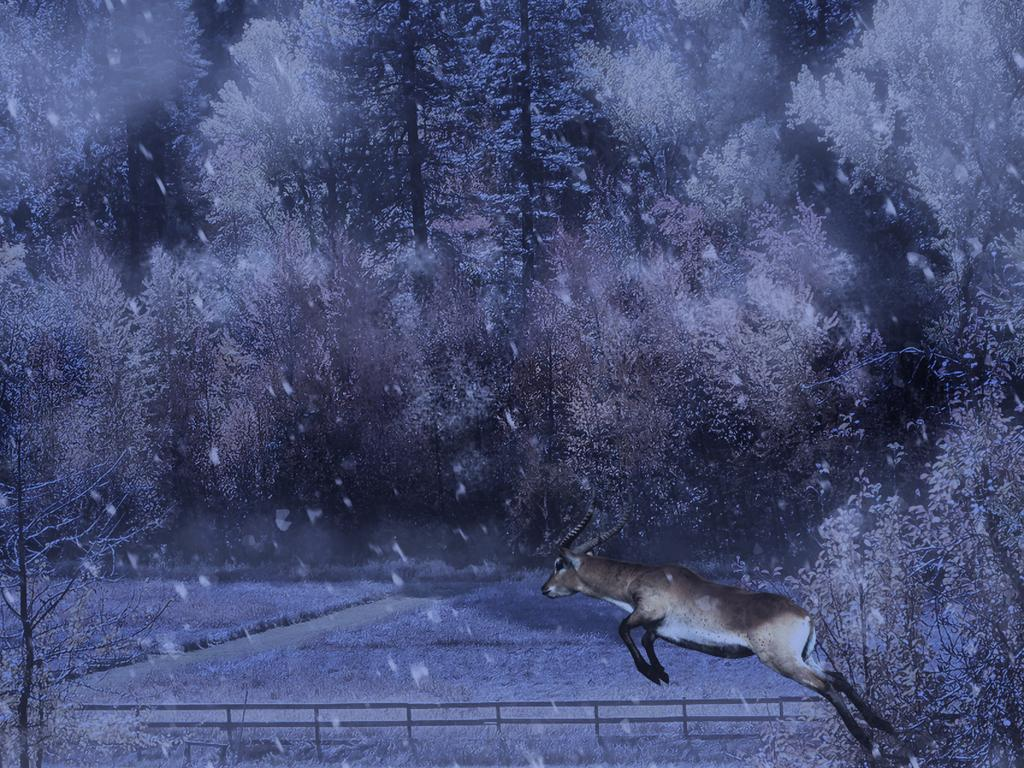What type of image is this? The image is animated. What natural elements can be seen in the image? There are trees and grass in the image. What weather condition is depicted in the image? There is snow in the image. What animal is present in the image? A deer is present in the image. What is the deer doing in the image? The deer is jumping over a fence. What type of wine is being served in the image? There is no wine present in the image; it is an animated scene featuring a deer jumping over a fence in a snowy environment. 